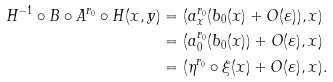Convert formula to latex. <formula><loc_0><loc_0><loc_500><loc_500>H ^ { - 1 } \circ B \circ A ^ { r _ { 0 } } \circ H ( x , y ) & = ( a _ { x } ^ { r _ { 0 } } ( b _ { 0 } ( x ) + O ( \varepsilon ) ) , x ) \\ & = ( a _ { 0 } ^ { r _ { 0 } } ( b _ { 0 } ( x ) ) + O ( \varepsilon ) , x ) \\ & = ( \eta ^ { r _ { 0 } } \circ \xi ( x ) + O ( \varepsilon ) , x ) .</formula> 